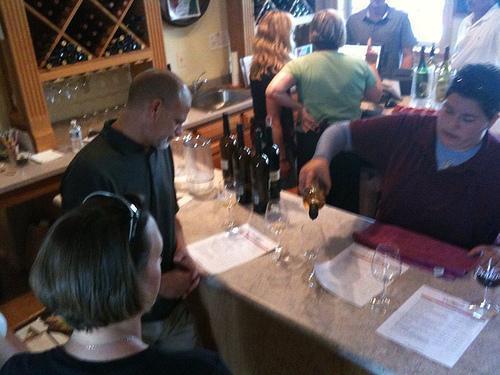How many people are on the left side of the counter?
Give a very brief answer. 2. How many people are in the photo?
Give a very brief answer. 7. How many people are there?
Give a very brief answer. 6. How many orange trucks are there?
Give a very brief answer. 0. 